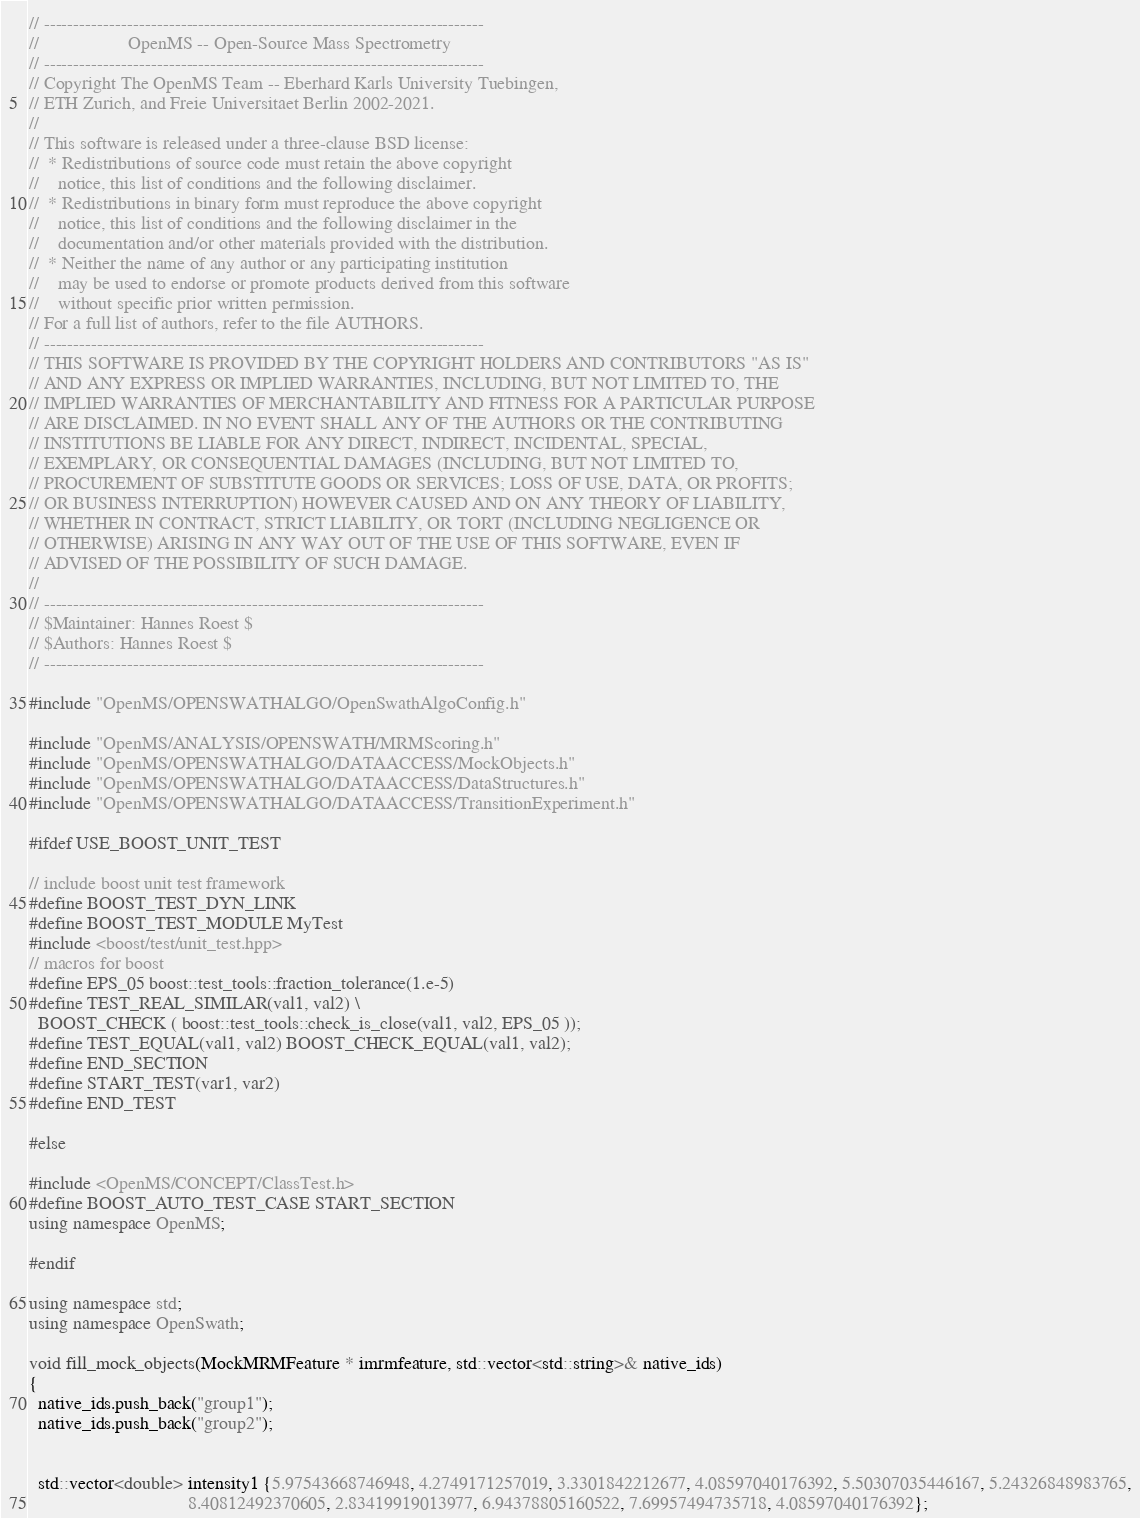<code> <loc_0><loc_0><loc_500><loc_500><_C++_>// --------------------------------------------------------------------------
//                   OpenMS -- Open-Source Mass Spectrometry
// --------------------------------------------------------------------------
// Copyright The OpenMS Team -- Eberhard Karls University Tuebingen,
// ETH Zurich, and Freie Universitaet Berlin 2002-2021.
//
// This software is released under a three-clause BSD license:
//  * Redistributions of source code must retain the above copyright
//    notice, this list of conditions and the following disclaimer.
//  * Redistributions in binary form must reproduce the above copyright
//    notice, this list of conditions and the following disclaimer in the
//    documentation and/or other materials provided with the distribution.
//  * Neither the name of any author or any participating institution
//    may be used to endorse or promote products derived from this software
//    without specific prior written permission.
// For a full list of authors, refer to the file AUTHORS.
// --------------------------------------------------------------------------
// THIS SOFTWARE IS PROVIDED BY THE COPYRIGHT HOLDERS AND CONTRIBUTORS "AS IS"
// AND ANY EXPRESS OR IMPLIED WARRANTIES, INCLUDING, BUT NOT LIMITED TO, THE
// IMPLIED WARRANTIES OF MERCHANTABILITY AND FITNESS FOR A PARTICULAR PURPOSE
// ARE DISCLAIMED. IN NO EVENT SHALL ANY OF THE AUTHORS OR THE CONTRIBUTING
// INSTITUTIONS BE LIABLE FOR ANY DIRECT, INDIRECT, INCIDENTAL, SPECIAL,
// EXEMPLARY, OR CONSEQUENTIAL DAMAGES (INCLUDING, BUT NOT LIMITED TO,
// PROCUREMENT OF SUBSTITUTE GOODS OR SERVICES; LOSS OF USE, DATA, OR PROFITS;
// OR BUSINESS INTERRUPTION) HOWEVER CAUSED AND ON ANY THEORY OF LIABILITY,
// WHETHER IN CONTRACT, STRICT LIABILITY, OR TORT (INCLUDING NEGLIGENCE OR
// OTHERWISE) ARISING IN ANY WAY OUT OF THE USE OF THIS SOFTWARE, EVEN IF
// ADVISED OF THE POSSIBILITY OF SUCH DAMAGE.
//
// --------------------------------------------------------------------------
// $Maintainer: Hannes Roest $
// $Authors: Hannes Roest $
// --------------------------------------------------------------------------

#include "OpenMS/OPENSWATHALGO/OpenSwathAlgoConfig.h"

#include "OpenMS/ANALYSIS/OPENSWATH/MRMScoring.h"
#include "OpenMS/OPENSWATHALGO/DATAACCESS/MockObjects.h"
#include "OpenMS/OPENSWATHALGO/DATAACCESS/DataStructures.h"
#include "OpenMS/OPENSWATHALGO/DATAACCESS/TransitionExperiment.h"

#ifdef USE_BOOST_UNIT_TEST

// include boost unit test framework
#define BOOST_TEST_DYN_LINK
#define BOOST_TEST_MODULE MyTest
#include <boost/test/unit_test.hpp>
// macros for boost
#define EPS_05 boost::test_tools::fraction_tolerance(1.e-5)
#define TEST_REAL_SIMILAR(val1, val2) \
  BOOST_CHECK ( boost::test_tools::check_is_close(val1, val2, EPS_05 ));
#define TEST_EQUAL(val1, val2) BOOST_CHECK_EQUAL(val1, val2);
#define END_SECTION
#define START_TEST(var1, var2)
#define END_TEST

#else

#include <OpenMS/CONCEPT/ClassTest.h>
#define BOOST_AUTO_TEST_CASE START_SECTION
using namespace OpenMS;

#endif

using namespace std;
using namespace OpenSwath;

void fill_mock_objects(MockMRMFeature * imrmfeature, std::vector<std::string>& native_ids)
{
  native_ids.push_back("group1");
  native_ids.push_back("group2");

  
  std::vector<double> intensity1 {5.97543668746948, 4.2749171257019, 3.3301842212677, 4.08597040176392, 5.50307035446167, 5.24326848983765,
                                  8.40812492370605, 2.83419919013977, 6.94378805160522, 7.69957494735718, 4.08597040176392};
</code> 